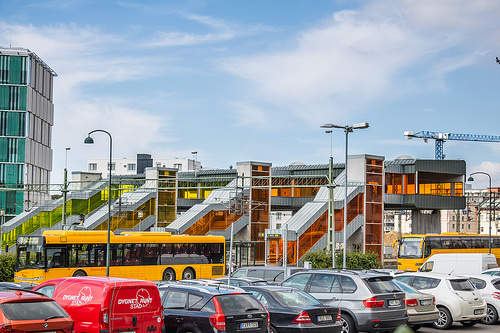<image>
Is there a bus on the car? No. The bus is not positioned on the car. They may be near each other, but the bus is not supported by or resting on top of the car. Where is the van in relation to the bus? Is it behind the bus? No. The van is not behind the bus. From this viewpoint, the van appears to be positioned elsewhere in the scene. 